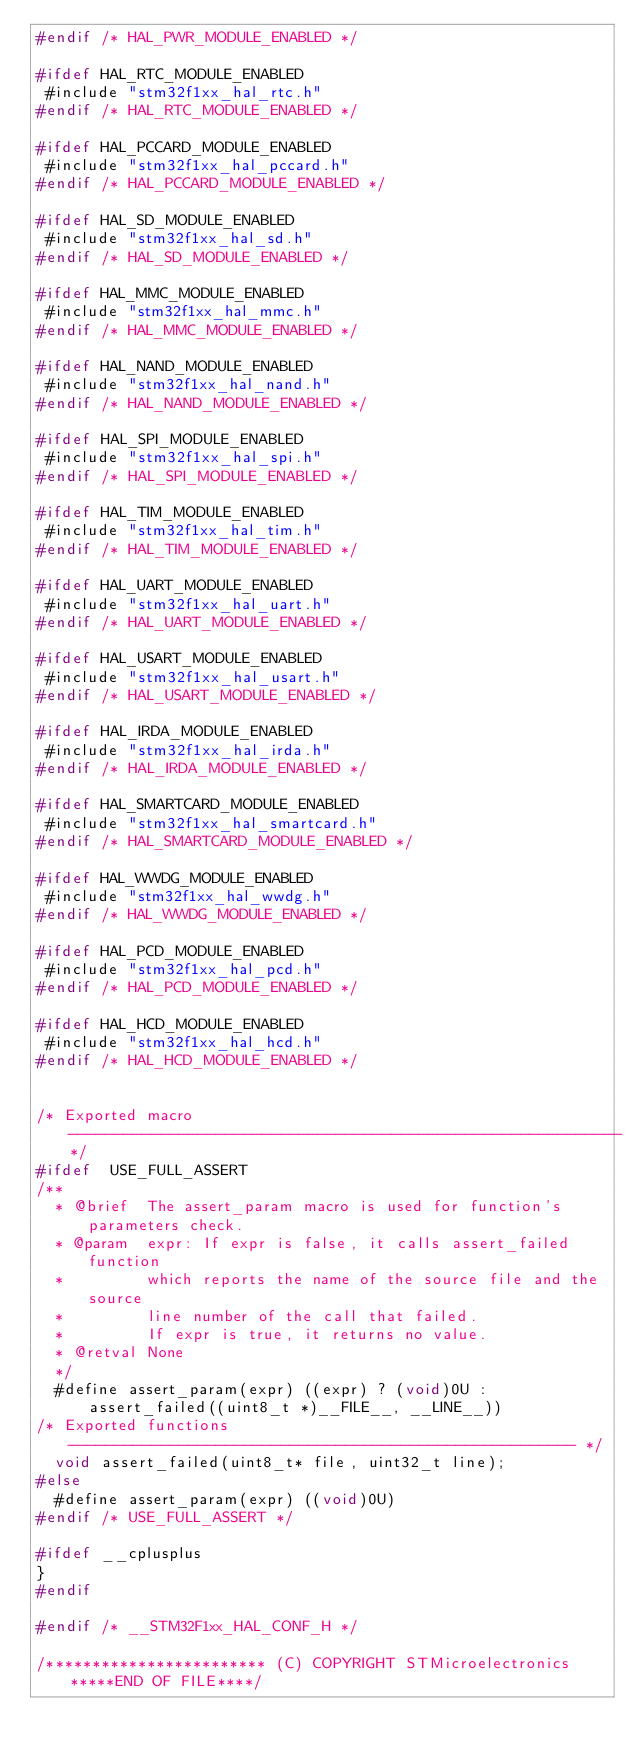Convert code to text. <code><loc_0><loc_0><loc_500><loc_500><_C_>#endif /* HAL_PWR_MODULE_ENABLED */

#ifdef HAL_RTC_MODULE_ENABLED
 #include "stm32f1xx_hal_rtc.h"
#endif /* HAL_RTC_MODULE_ENABLED */

#ifdef HAL_PCCARD_MODULE_ENABLED
 #include "stm32f1xx_hal_pccard.h"
#endif /* HAL_PCCARD_MODULE_ENABLED */ 

#ifdef HAL_SD_MODULE_ENABLED
 #include "stm32f1xx_hal_sd.h"
#endif /* HAL_SD_MODULE_ENABLED */  

#ifdef HAL_MMC_MODULE_ENABLED
 #include "stm32f1xx_hal_mmc.h"
#endif /* HAL_MMC_MODULE_ENABLED */

#ifdef HAL_NAND_MODULE_ENABLED
 #include "stm32f1xx_hal_nand.h"
#endif /* HAL_NAND_MODULE_ENABLED */     

#ifdef HAL_SPI_MODULE_ENABLED
 #include "stm32f1xx_hal_spi.h"
#endif /* HAL_SPI_MODULE_ENABLED */

#ifdef HAL_TIM_MODULE_ENABLED
 #include "stm32f1xx_hal_tim.h"
#endif /* HAL_TIM_MODULE_ENABLED */

#ifdef HAL_UART_MODULE_ENABLED
 #include "stm32f1xx_hal_uart.h"
#endif /* HAL_UART_MODULE_ENABLED */

#ifdef HAL_USART_MODULE_ENABLED
 #include "stm32f1xx_hal_usart.h"
#endif /* HAL_USART_MODULE_ENABLED */

#ifdef HAL_IRDA_MODULE_ENABLED
 #include "stm32f1xx_hal_irda.h"
#endif /* HAL_IRDA_MODULE_ENABLED */

#ifdef HAL_SMARTCARD_MODULE_ENABLED
 #include "stm32f1xx_hal_smartcard.h"
#endif /* HAL_SMARTCARD_MODULE_ENABLED */

#ifdef HAL_WWDG_MODULE_ENABLED
 #include "stm32f1xx_hal_wwdg.h"
#endif /* HAL_WWDG_MODULE_ENABLED */

#ifdef HAL_PCD_MODULE_ENABLED
 #include "stm32f1xx_hal_pcd.h"
#endif /* HAL_PCD_MODULE_ENABLED */

#ifdef HAL_HCD_MODULE_ENABLED
 #include "stm32f1xx_hal_hcd.h"
#endif /* HAL_HCD_MODULE_ENABLED */   
   

/* Exported macro ------------------------------------------------------------*/
#ifdef  USE_FULL_ASSERT
/**
  * @brief  The assert_param macro is used for function's parameters check.
  * @param  expr: If expr is false, it calls assert_failed function
  *         which reports the name of the source file and the source
  *         line number of the call that failed. 
  *         If expr is true, it returns no value.
  * @retval None
  */
  #define assert_param(expr) ((expr) ? (void)0U : assert_failed((uint8_t *)__FILE__, __LINE__))
/* Exported functions ------------------------------------------------------- */
  void assert_failed(uint8_t* file, uint32_t line);
#else
  #define assert_param(expr) ((void)0U)
#endif /* USE_FULL_ASSERT */

#ifdef __cplusplus
}
#endif

#endif /* __STM32F1xx_HAL_CONF_H */

/************************ (C) COPYRIGHT STMicroelectronics *****END OF FILE****/
</code> 